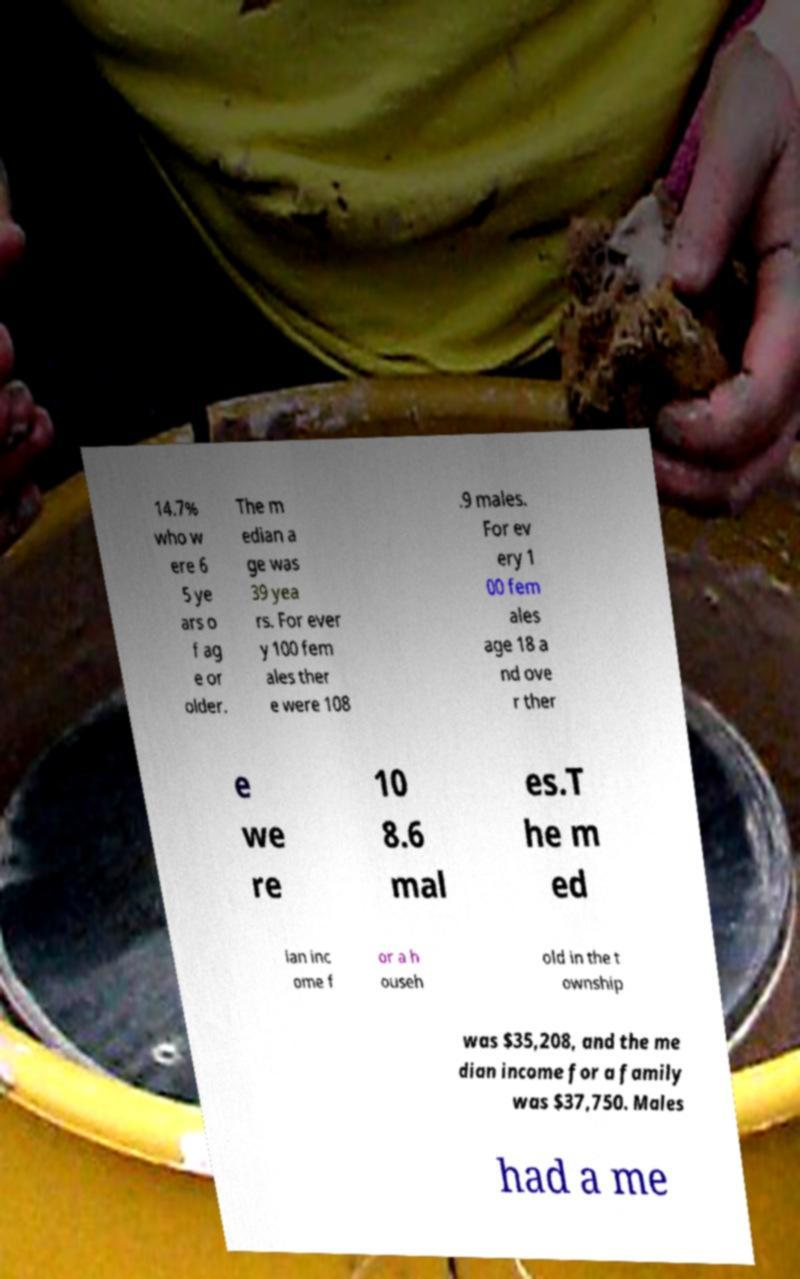There's text embedded in this image that I need extracted. Can you transcribe it verbatim? 14.7% who w ere 6 5 ye ars o f ag e or older. The m edian a ge was 39 yea rs. For ever y 100 fem ales ther e were 108 .9 males. For ev ery 1 00 fem ales age 18 a nd ove r ther e we re 10 8.6 mal es.T he m ed ian inc ome f or a h ouseh old in the t ownship was $35,208, and the me dian income for a family was $37,750. Males had a me 